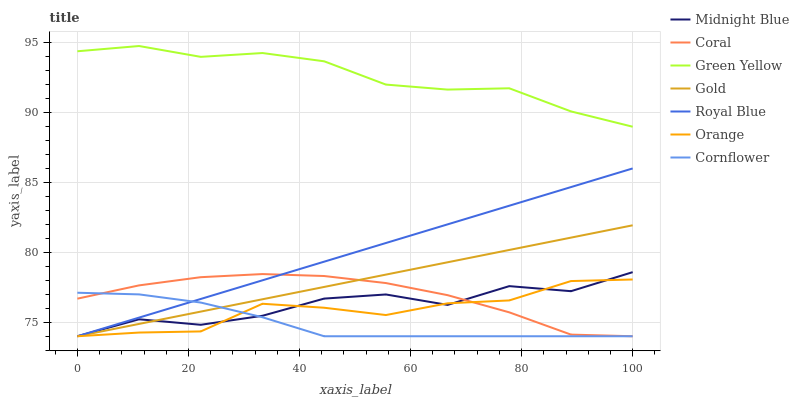Does Cornflower have the minimum area under the curve?
Answer yes or no. Yes. Does Green Yellow have the maximum area under the curve?
Answer yes or no. Yes. Does Midnight Blue have the minimum area under the curve?
Answer yes or no. No. Does Midnight Blue have the maximum area under the curve?
Answer yes or no. No. Is Royal Blue the smoothest?
Answer yes or no. Yes. Is Midnight Blue the roughest?
Answer yes or no. Yes. Is Gold the smoothest?
Answer yes or no. No. Is Gold the roughest?
Answer yes or no. No. Does Cornflower have the lowest value?
Answer yes or no. Yes. Does Green Yellow have the lowest value?
Answer yes or no. No. Does Green Yellow have the highest value?
Answer yes or no. Yes. Does Midnight Blue have the highest value?
Answer yes or no. No. Is Midnight Blue less than Green Yellow?
Answer yes or no. Yes. Is Green Yellow greater than Coral?
Answer yes or no. Yes. Does Orange intersect Gold?
Answer yes or no. Yes. Is Orange less than Gold?
Answer yes or no. No. Is Orange greater than Gold?
Answer yes or no. No. Does Midnight Blue intersect Green Yellow?
Answer yes or no. No. 